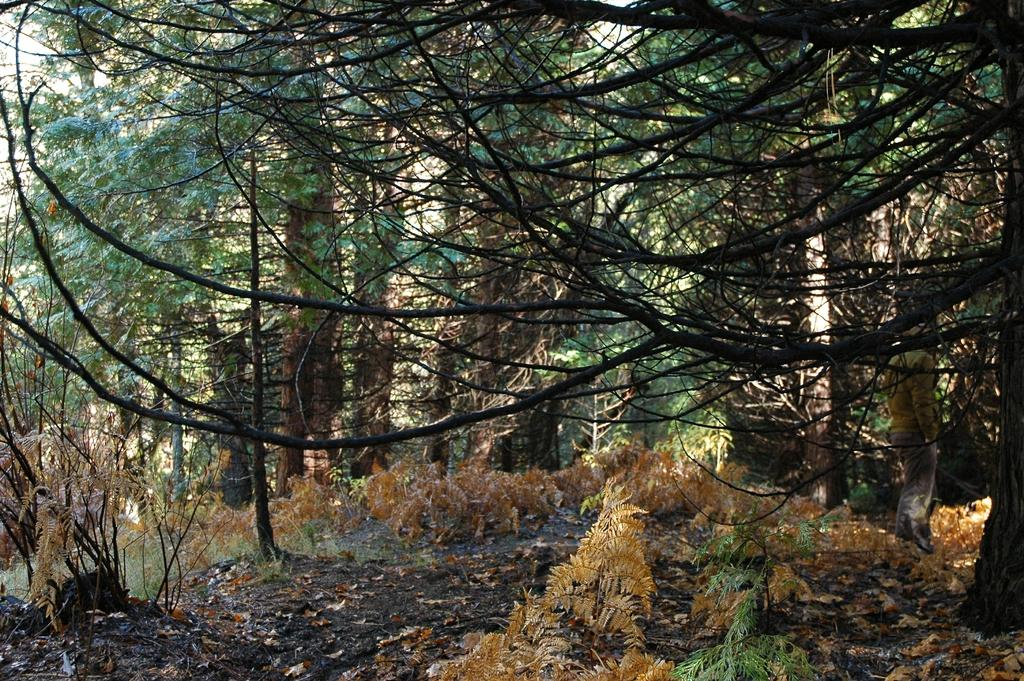What type of vegetation can be seen in the image? There are trees and plants in the image. What part of the natural environment is visible in the image? The sky is visible in the image. Can you tell me how many rabbits are jumping in the verse in the image? There are no rabbits or verses present in the image; it features trees, plants, and the sky. 